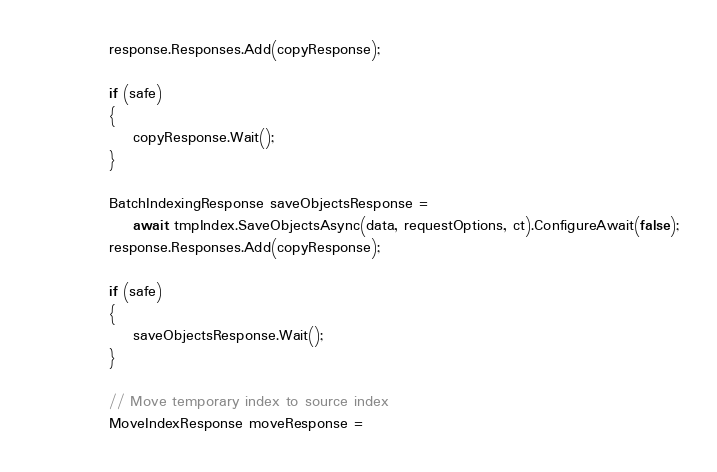Convert code to text. <code><loc_0><loc_0><loc_500><loc_500><_C#_>            response.Responses.Add(copyResponse);

            if (safe)
            {
                copyResponse.Wait();
            }

            BatchIndexingResponse saveObjectsResponse =
                await tmpIndex.SaveObjectsAsync(data, requestOptions, ct).ConfigureAwait(false);
            response.Responses.Add(copyResponse);

            if (safe)
            {
                saveObjectsResponse.Wait();
            }

            // Move temporary index to source index
            MoveIndexResponse moveResponse =</code> 